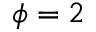Convert formula to latex. <formula><loc_0><loc_0><loc_500><loc_500>\phi = 2</formula> 